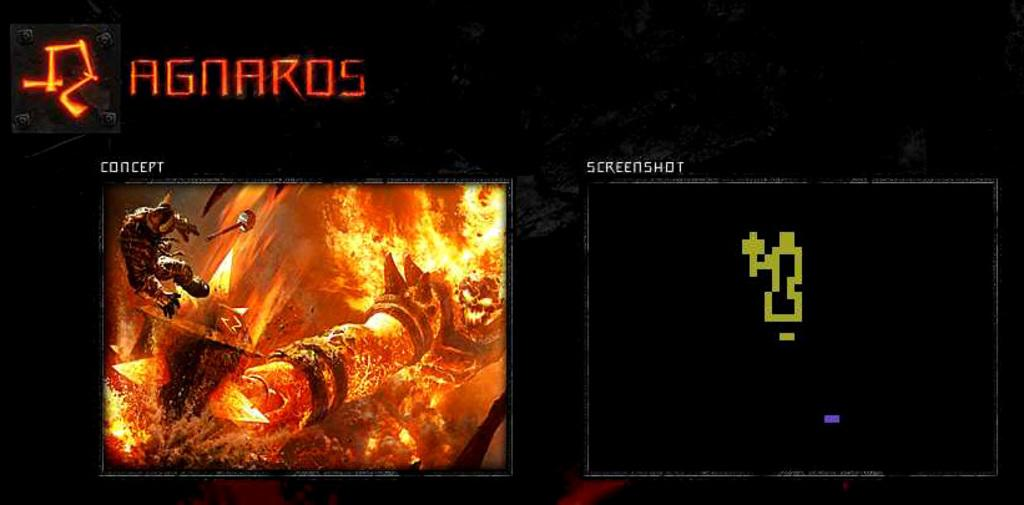<image>
Describe the image concisely. a digital sign above a screen that says 'agnakos' on it 